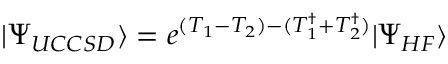<formula> <loc_0><loc_0><loc_500><loc_500>| \Psi _ { U C C S D } \rangle = e ^ { ( T _ { 1 } - T _ { 2 } ) - ( T _ { 1 } ^ { \dagger } + T _ { 2 } ^ { \dagger } ) } | \Psi _ { H F } \rangle</formula> 